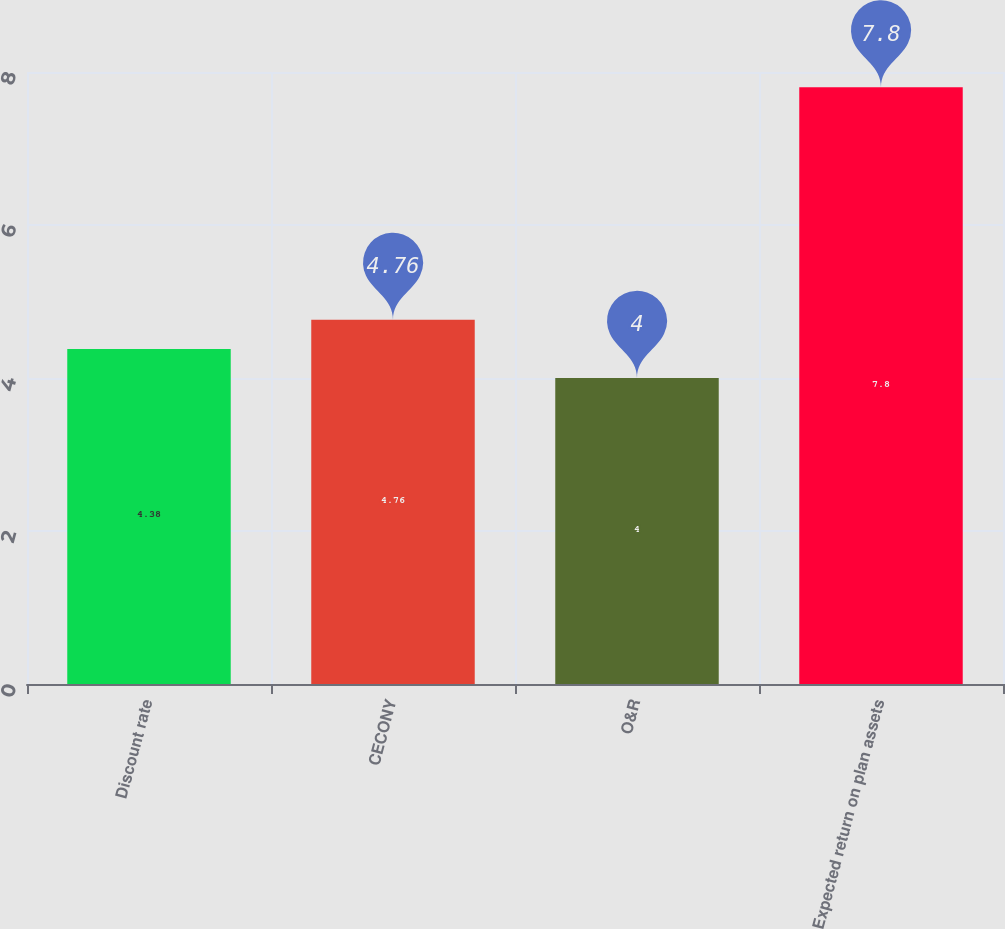Convert chart to OTSL. <chart><loc_0><loc_0><loc_500><loc_500><bar_chart><fcel>Discount rate<fcel>CECONY<fcel>O&R<fcel>Expected return on plan assets<nl><fcel>4.38<fcel>4.76<fcel>4<fcel>7.8<nl></chart> 